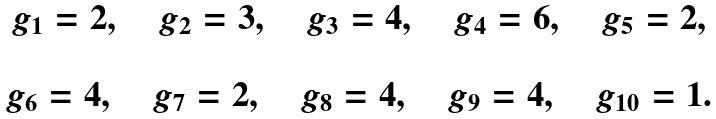Convert formula to latex. <formula><loc_0><loc_0><loc_500><loc_500>\begin{array} { c } g _ { 1 } = 2 , \quad g _ { 2 } = 3 , \quad g _ { 3 } = 4 , \quad g _ { 4 } = 6 , \quad g _ { 5 } = 2 , \\ \\ g _ { 6 } = 4 , \quad g _ { 7 } = 2 , \quad g _ { 8 } = 4 , \quad g _ { 9 } = 4 , \quad g _ { 1 0 } = 1 . \\ \end{array}</formula> 